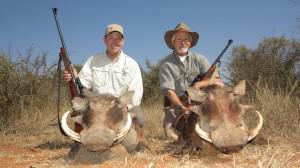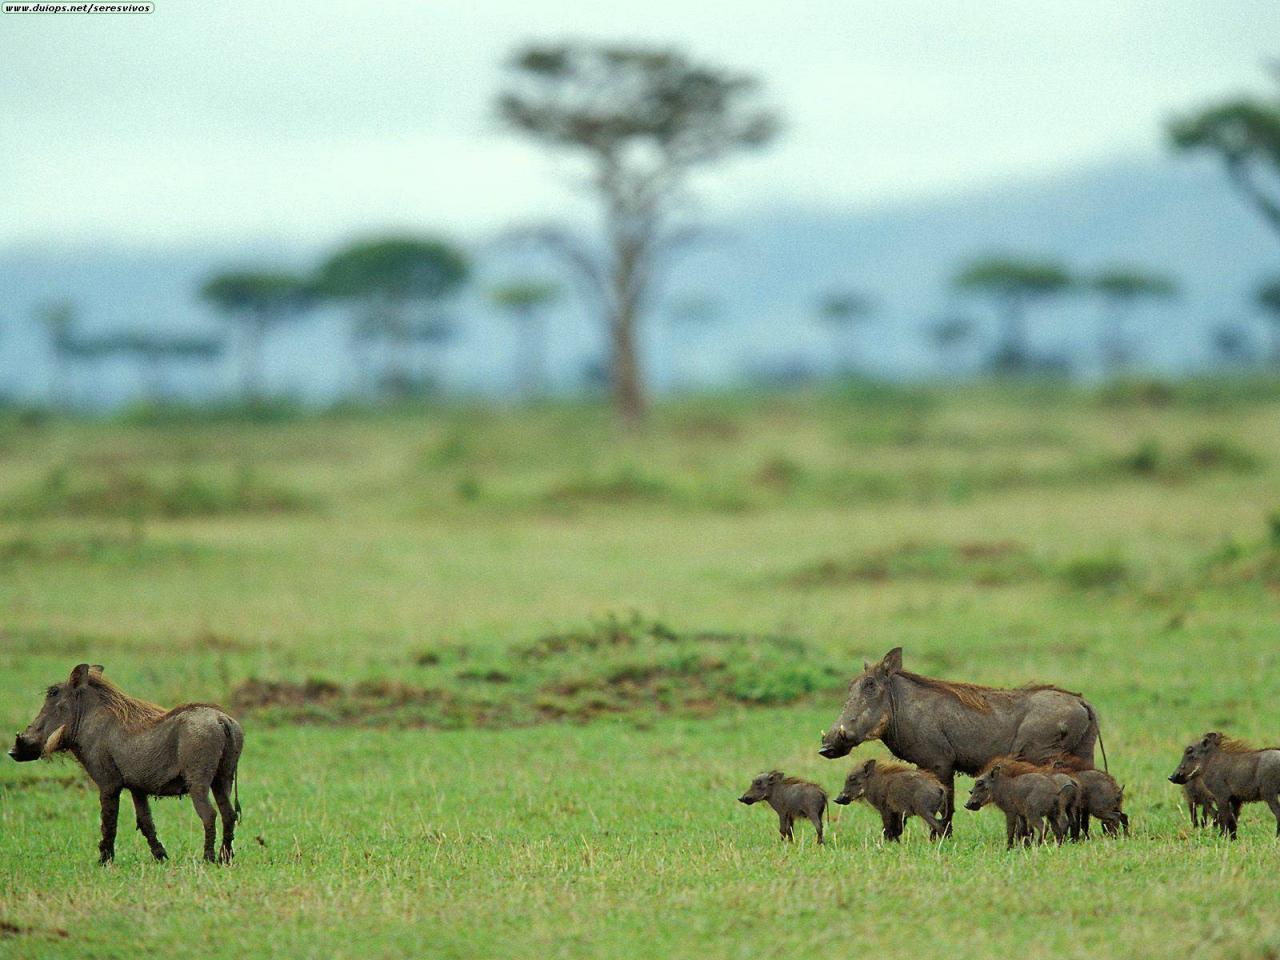The first image is the image on the left, the second image is the image on the right. Analyze the images presented: Is the assertion "there are three baby animals in the image on the right" valid? Answer yes or no. Yes. The first image is the image on the left, the second image is the image on the right. Considering the images on both sides, is "One image includes a predator of the warthog." valid? Answer yes or no. Yes. 